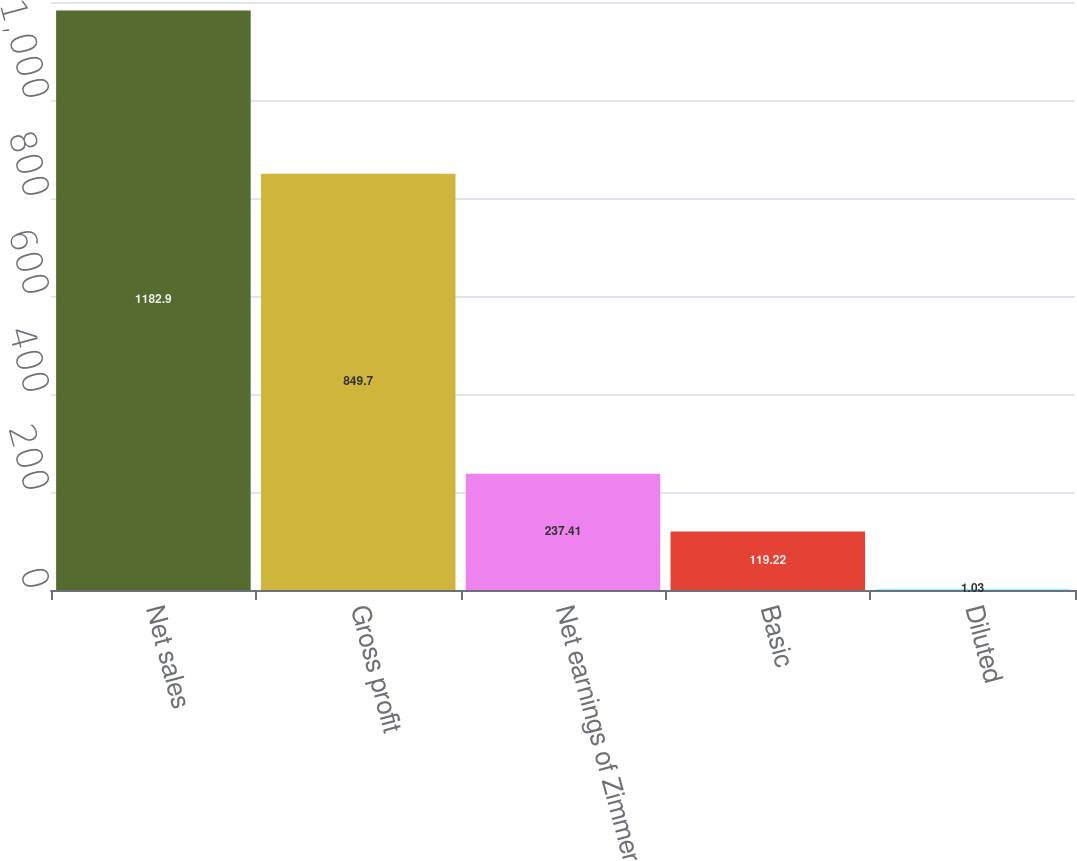<chart> <loc_0><loc_0><loc_500><loc_500><bar_chart><fcel>Net sales<fcel>Gross profit<fcel>Net earnings of Zimmer<fcel>Basic<fcel>Diluted<nl><fcel>1182.9<fcel>849.7<fcel>237.41<fcel>119.22<fcel>1.03<nl></chart> 